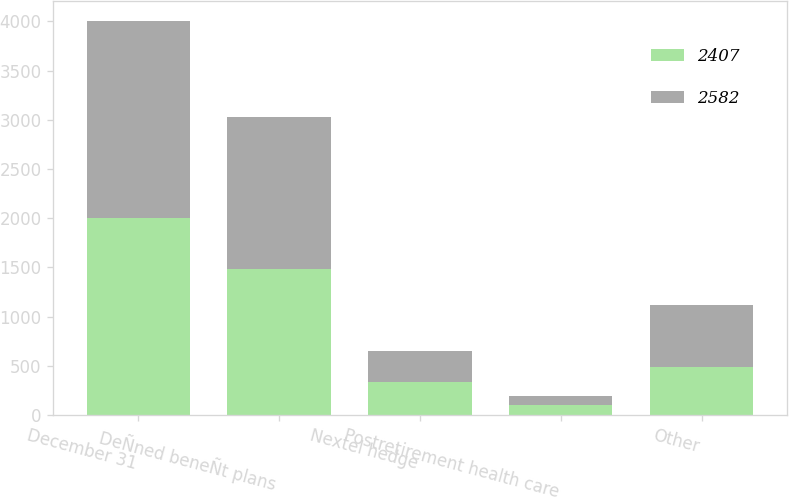Convert chart to OTSL. <chart><loc_0><loc_0><loc_500><loc_500><stacked_bar_chart><ecel><fcel>December 31<fcel>DeÑned beneÑt plans<fcel>Nextel hedge<fcel>Postretirement health care<fcel>Other<nl><fcel>2407<fcel>2004<fcel>1481<fcel>340<fcel>100<fcel>486<nl><fcel>2582<fcel>2003<fcel>1546<fcel>310<fcel>90<fcel>636<nl></chart> 